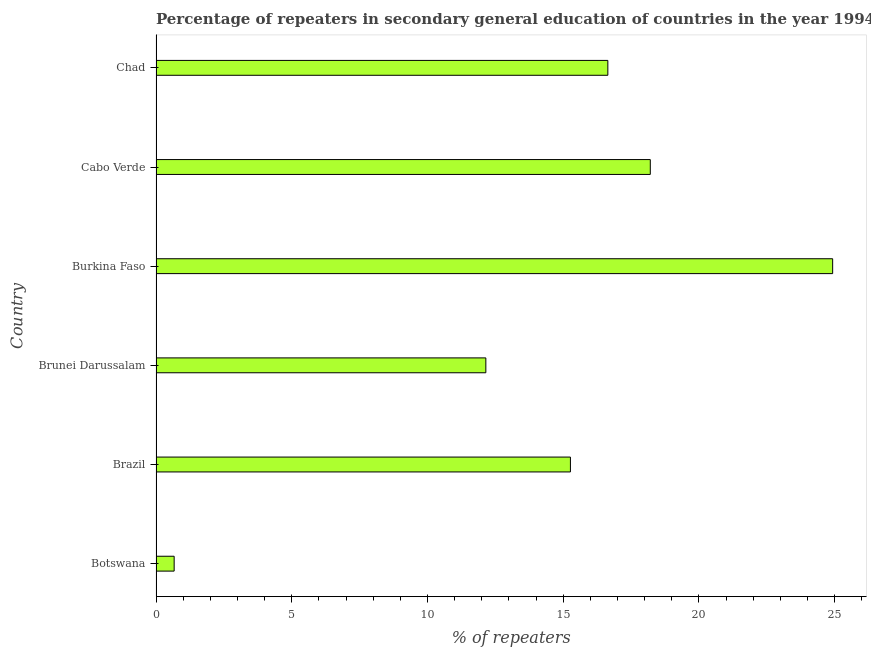Does the graph contain grids?
Make the answer very short. No. What is the title of the graph?
Offer a terse response. Percentage of repeaters in secondary general education of countries in the year 1994. What is the label or title of the X-axis?
Your response must be concise. % of repeaters. What is the percentage of repeaters in Brunei Darussalam?
Give a very brief answer. 12.15. Across all countries, what is the maximum percentage of repeaters?
Offer a terse response. 24.93. Across all countries, what is the minimum percentage of repeaters?
Your answer should be compact. 0.67. In which country was the percentage of repeaters maximum?
Your response must be concise. Burkina Faso. In which country was the percentage of repeaters minimum?
Give a very brief answer. Botswana. What is the sum of the percentage of repeaters?
Your response must be concise. 87.86. What is the difference between the percentage of repeaters in Brazil and Chad?
Offer a very short reply. -1.38. What is the average percentage of repeaters per country?
Your answer should be compact. 14.64. What is the median percentage of repeaters?
Offer a very short reply. 15.95. In how many countries, is the percentage of repeaters greater than 11 %?
Your response must be concise. 5. What is the ratio of the percentage of repeaters in Brazil to that in Cabo Verde?
Make the answer very short. 0.84. Is the percentage of repeaters in Brazil less than that in Brunei Darussalam?
Offer a very short reply. No. What is the difference between the highest and the second highest percentage of repeaters?
Your response must be concise. 6.72. Is the sum of the percentage of repeaters in Brunei Darussalam and Burkina Faso greater than the maximum percentage of repeaters across all countries?
Give a very brief answer. Yes. What is the difference between the highest and the lowest percentage of repeaters?
Your response must be concise. 24.26. How many bars are there?
Give a very brief answer. 6. Are all the bars in the graph horizontal?
Offer a terse response. Yes. How many countries are there in the graph?
Give a very brief answer. 6. What is the difference between two consecutive major ticks on the X-axis?
Keep it short and to the point. 5. What is the % of repeaters in Botswana?
Offer a very short reply. 0.67. What is the % of repeaters of Brazil?
Offer a very short reply. 15.27. What is the % of repeaters of Brunei Darussalam?
Keep it short and to the point. 12.15. What is the % of repeaters in Burkina Faso?
Offer a very short reply. 24.93. What is the % of repeaters in Cabo Verde?
Give a very brief answer. 18.21. What is the % of repeaters of Chad?
Offer a very short reply. 16.64. What is the difference between the % of repeaters in Botswana and Brazil?
Keep it short and to the point. -14.6. What is the difference between the % of repeaters in Botswana and Brunei Darussalam?
Provide a succinct answer. -11.48. What is the difference between the % of repeaters in Botswana and Burkina Faso?
Your answer should be compact. -24.26. What is the difference between the % of repeaters in Botswana and Cabo Verde?
Make the answer very short. -17.54. What is the difference between the % of repeaters in Botswana and Chad?
Ensure brevity in your answer.  -15.98. What is the difference between the % of repeaters in Brazil and Brunei Darussalam?
Offer a terse response. 3.12. What is the difference between the % of repeaters in Brazil and Burkina Faso?
Offer a terse response. -9.66. What is the difference between the % of repeaters in Brazil and Cabo Verde?
Provide a succinct answer. -2.94. What is the difference between the % of repeaters in Brazil and Chad?
Offer a terse response. -1.38. What is the difference between the % of repeaters in Brunei Darussalam and Burkina Faso?
Your answer should be very brief. -12.78. What is the difference between the % of repeaters in Brunei Darussalam and Cabo Verde?
Provide a short and direct response. -6.06. What is the difference between the % of repeaters in Brunei Darussalam and Chad?
Your answer should be compact. -4.49. What is the difference between the % of repeaters in Burkina Faso and Cabo Verde?
Offer a very short reply. 6.72. What is the difference between the % of repeaters in Burkina Faso and Chad?
Your answer should be compact. 8.28. What is the difference between the % of repeaters in Cabo Verde and Chad?
Ensure brevity in your answer.  1.56. What is the ratio of the % of repeaters in Botswana to that in Brazil?
Your answer should be compact. 0.04. What is the ratio of the % of repeaters in Botswana to that in Brunei Darussalam?
Your response must be concise. 0.06. What is the ratio of the % of repeaters in Botswana to that in Burkina Faso?
Offer a very short reply. 0.03. What is the ratio of the % of repeaters in Botswana to that in Cabo Verde?
Your answer should be compact. 0.04. What is the ratio of the % of repeaters in Botswana to that in Chad?
Your answer should be very brief. 0.04. What is the ratio of the % of repeaters in Brazil to that in Brunei Darussalam?
Your response must be concise. 1.26. What is the ratio of the % of repeaters in Brazil to that in Burkina Faso?
Ensure brevity in your answer.  0.61. What is the ratio of the % of repeaters in Brazil to that in Cabo Verde?
Ensure brevity in your answer.  0.84. What is the ratio of the % of repeaters in Brazil to that in Chad?
Give a very brief answer. 0.92. What is the ratio of the % of repeaters in Brunei Darussalam to that in Burkina Faso?
Ensure brevity in your answer.  0.49. What is the ratio of the % of repeaters in Brunei Darussalam to that in Cabo Verde?
Make the answer very short. 0.67. What is the ratio of the % of repeaters in Brunei Darussalam to that in Chad?
Provide a succinct answer. 0.73. What is the ratio of the % of repeaters in Burkina Faso to that in Cabo Verde?
Your answer should be compact. 1.37. What is the ratio of the % of repeaters in Burkina Faso to that in Chad?
Keep it short and to the point. 1.5. What is the ratio of the % of repeaters in Cabo Verde to that in Chad?
Keep it short and to the point. 1.09. 